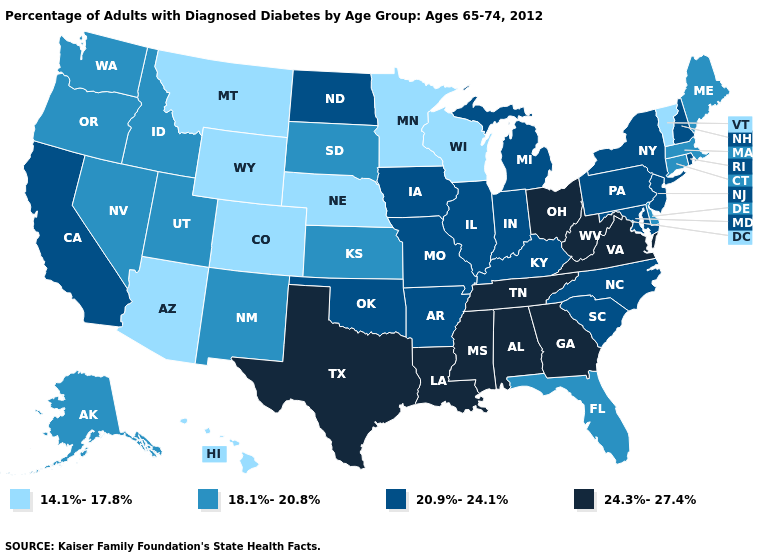Among the states that border Arkansas , which have the highest value?
Concise answer only. Louisiana, Mississippi, Tennessee, Texas. Name the states that have a value in the range 14.1%-17.8%?
Concise answer only. Arizona, Colorado, Hawaii, Minnesota, Montana, Nebraska, Vermont, Wisconsin, Wyoming. Which states have the lowest value in the South?
Keep it brief. Delaware, Florida. Name the states that have a value in the range 20.9%-24.1%?
Short answer required. Arkansas, California, Illinois, Indiana, Iowa, Kentucky, Maryland, Michigan, Missouri, New Hampshire, New Jersey, New York, North Carolina, North Dakota, Oklahoma, Pennsylvania, Rhode Island, South Carolina. What is the lowest value in states that border Idaho?
Write a very short answer. 14.1%-17.8%. What is the highest value in the USA?
Short answer required. 24.3%-27.4%. Does Georgia have the same value as Pennsylvania?
Give a very brief answer. No. What is the value of Arkansas?
Give a very brief answer. 20.9%-24.1%. What is the lowest value in states that border Utah?
Short answer required. 14.1%-17.8%. Name the states that have a value in the range 24.3%-27.4%?
Short answer required. Alabama, Georgia, Louisiana, Mississippi, Ohio, Tennessee, Texas, Virginia, West Virginia. What is the value of South Dakota?
Concise answer only. 18.1%-20.8%. What is the value of Alabama?
Answer briefly. 24.3%-27.4%. What is the value of Indiana?
Answer briefly. 20.9%-24.1%. Which states hav the highest value in the West?
Keep it brief. California. What is the value of Vermont?
Keep it brief. 14.1%-17.8%. 